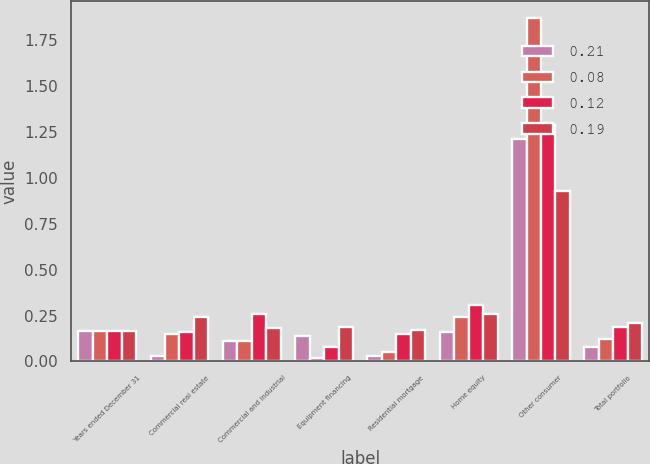Convert chart to OTSL. <chart><loc_0><loc_0><loc_500><loc_500><stacked_bar_chart><ecel><fcel>Years ended December 31<fcel>Commercial real estate<fcel>Commercial and industrial<fcel>Equipment financing<fcel>Residential mortgage<fcel>Home equity<fcel>Other consumer<fcel>Total portfolio<nl><fcel>0.21<fcel>0.165<fcel>0.03<fcel>0.11<fcel>0.14<fcel>0.03<fcel>0.16<fcel>1.21<fcel>0.08<nl><fcel>0.08<fcel>0.165<fcel>0.15<fcel>0.11<fcel>0.02<fcel>0.05<fcel>0.24<fcel>1.87<fcel>0.12<nl><fcel>0.12<fcel>0.165<fcel>0.16<fcel>0.26<fcel>0.08<fcel>0.15<fcel>0.31<fcel>1.29<fcel>0.19<nl><fcel>0.19<fcel>0.165<fcel>0.24<fcel>0.18<fcel>0.19<fcel>0.17<fcel>0.26<fcel>0.93<fcel>0.21<nl></chart> 